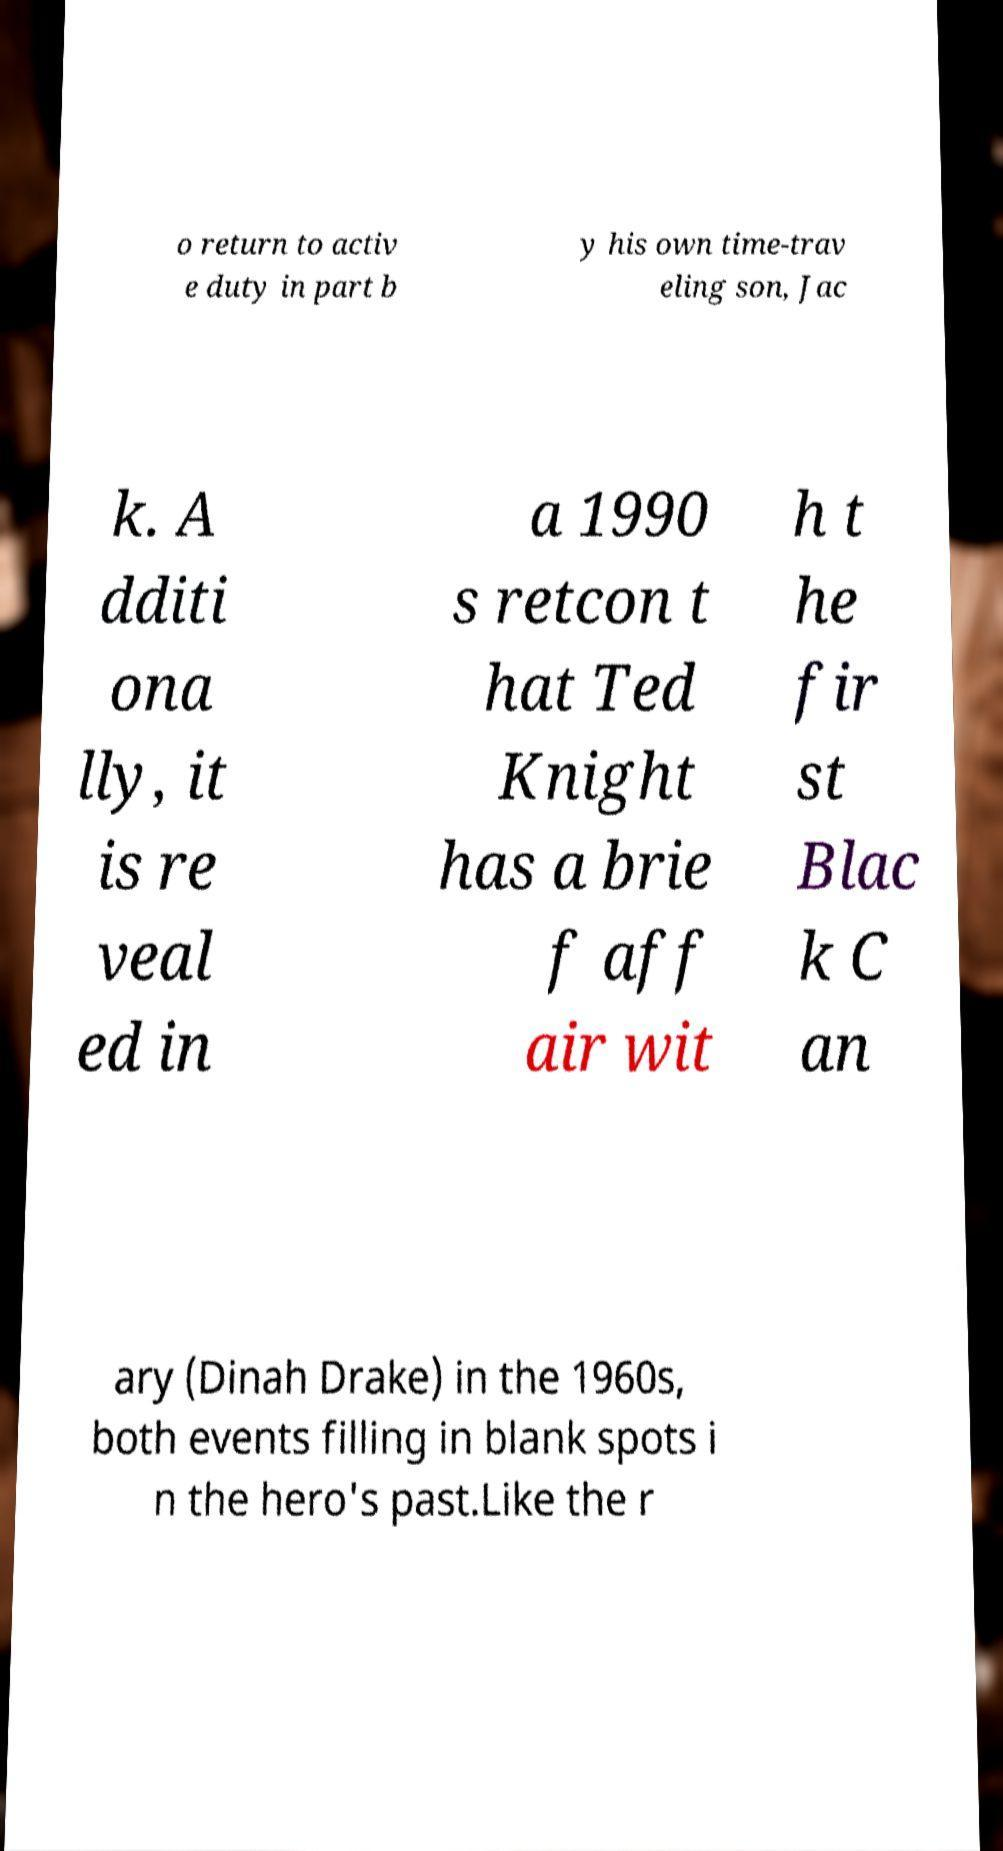For documentation purposes, I need the text within this image transcribed. Could you provide that? o return to activ e duty in part b y his own time-trav eling son, Jac k. A dditi ona lly, it is re veal ed in a 1990 s retcon t hat Ted Knight has a brie f aff air wit h t he fir st Blac k C an ary (Dinah Drake) in the 1960s, both events filling in blank spots i n the hero's past.Like the r 